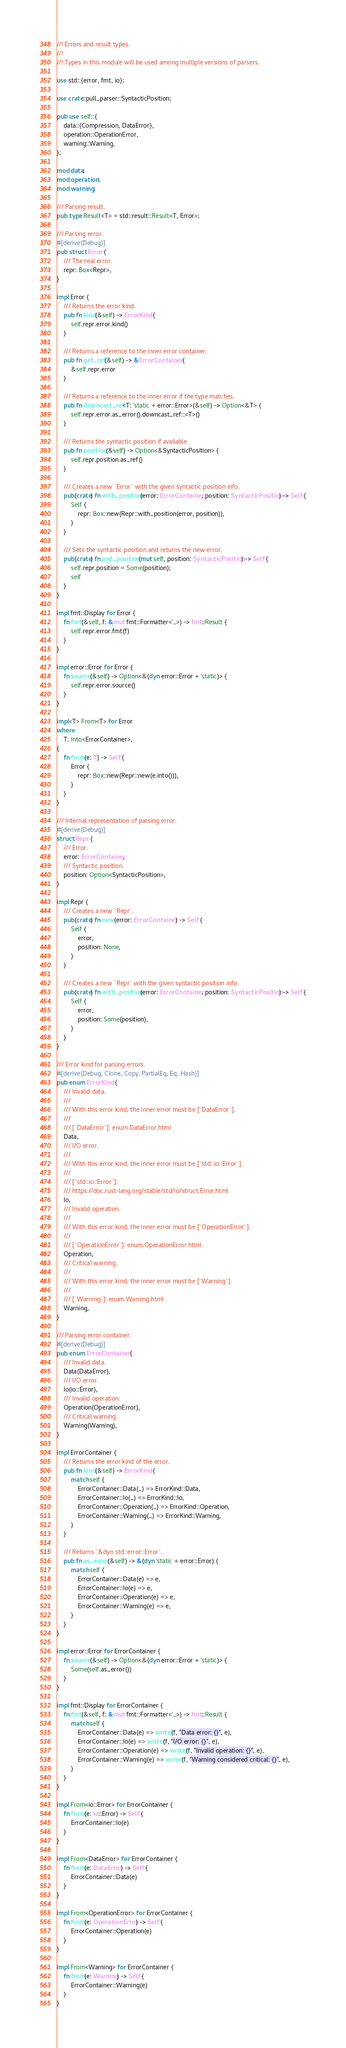Convert code to text. <code><loc_0><loc_0><loc_500><loc_500><_Rust_>//! Errors and result types.
//!
//! Types in this module will be used among multiple versions of parsers.

use std::{error, fmt, io};

use crate::pull_parser::SyntacticPosition;

pub use self::{
    data::{Compression, DataError},
    operation::OperationError,
    warning::Warning,
};

mod data;
mod operation;
mod warning;

/// Parsing result.
pub type Result<T> = std::result::Result<T, Error>;

/// Parsing error.
#[derive(Debug)]
pub struct Error {
    /// The real error.
    repr: Box<Repr>,
}

impl Error {
    /// Returns the error kind.
    pub fn kind(&self) -> ErrorKind {
        self.repr.error.kind()
    }

    /// Returns a reference to the inner error container.
    pub fn get_ref(&self) -> &ErrorContainer {
        &self.repr.error
    }

    /// Returns a reference to the inner error if the type matches.
    pub fn downcast_ref<T: 'static + error::Error>(&self) -> Option<&T> {
        self.repr.error.as_error().downcast_ref::<T>()
    }

    /// Returns the syntactic position if available.
    pub fn position(&self) -> Option<&SyntacticPosition> {
        self.repr.position.as_ref()
    }

    /// Creates a new `Error` with the given syntactic position info.
    pub(crate) fn with_position(error: ErrorContainer, position: SyntacticPosition) -> Self {
        Self {
            repr: Box::new(Repr::with_position(error, position)),
        }
    }

    /// Sets the syntactic position and returns the new error.
    pub(crate) fn and_position(mut self, position: SyntacticPosition) -> Self {
        self.repr.position = Some(position);
        self
    }
}

impl fmt::Display for Error {
    fn fmt(&self, f: &mut fmt::Formatter<'_>) -> fmt::Result {
        self.repr.error.fmt(f)
    }
}

impl error::Error for Error {
    fn source(&self) -> Option<&(dyn error::Error + 'static)> {
        self.repr.error.source()
    }
}

impl<T> From<T> for Error
where
    T: Into<ErrorContainer>,
{
    fn from(e: T) -> Self {
        Error {
            repr: Box::new(Repr::new(e.into())),
        }
    }
}

/// Internal representation of parsing error.
#[derive(Debug)]
struct Repr {
    /// Error.
    error: ErrorContainer,
    /// Syntactic position.
    position: Option<SyntacticPosition>,
}

impl Repr {
    /// Creates a new `Repr`.
    pub(crate) fn new(error: ErrorContainer) -> Self {
        Self {
            error,
            position: None,
        }
    }

    /// Creates a new `Repr` with the given syntactic position info.
    pub(crate) fn with_position(error: ErrorContainer, position: SyntacticPosition) -> Self {
        Self {
            error,
            position: Some(position),
        }
    }
}

/// Error kind for parsing errors.
#[derive(Debug, Clone, Copy, PartialEq, Eq, Hash)]
pub enum ErrorKind {
    /// Invalid data.
    ///
    /// With this error kind, the inner error must be [`DataError`].
    ///
    /// [`DataError`]: enum.DataError.html
    Data,
    /// I/O error.
    ///
    /// With this error kind, the inner error must be [`std::io::Error`].
    ///
    /// [`std::io::Error`]:
    /// https://doc.rust-lang.org/stable/std/io/struct.Error.html
    Io,
    /// Invalid operation.
    ///
    /// With this error kind, the inner error must be [`OperationError`].
    ///
    /// [`OperationError`]: enum.OperationError.html
    Operation,
    /// Critical warning.
    ///
    /// With this error kind, the inner error must be [`Warning`].
    ///
    /// [`Warning`]: enum.Warning.html
    Warning,
}

/// Parsing error container.
#[derive(Debug)]
pub enum ErrorContainer {
    /// Invalid data.
    Data(DataError),
    /// I/O error.
    Io(io::Error),
    /// Invalid operation.
    Operation(OperationError),
    /// Critical warning.
    Warning(Warning),
}

impl ErrorContainer {
    /// Returns the error kind of the error.
    pub fn kind(&self) -> ErrorKind {
        match self {
            ErrorContainer::Data(_) => ErrorKind::Data,
            ErrorContainer::Io(_) => ErrorKind::Io,
            ErrorContainer::Operation(_) => ErrorKind::Operation,
            ErrorContainer::Warning(_) => ErrorKind::Warning,
        }
    }

    /// Returns `&dyn std::error::Error`.
    pub fn as_error(&self) -> &(dyn 'static + error::Error) {
        match self {
            ErrorContainer::Data(e) => e,
            ErrorContainer::Io(e) => e,
            ErrorContainer::Operation(e) => e,
            ErrorContainer::Warning(e) => e,
        }
    }
}

impl error::Error for ErrorContainer {
    fn source(&self) -> Option<&(dyn error::Error + 'static)> {
        Some(self.as_error())
    }
}

impl fmt::Display for ErrorContainer {
    fn fmt(&self, f: &mut fmt::Formatter<'_>) -> fmt::Result {
        match self {
            ErrorContainer::Data(e) => write!(f, "Data error: {}", e),
            ErrorContainer::Io(e) => write!(f, "I/O error: {}", e),
            ErrorContainer::Operation(e) => write!(f, "Invalid operation: {}", e),
            ErrorContainer::Warning(e) => write!(f, "Warning considered critical: {}", e),
        }
    }
}

impl From<io::Error> for ErrorContainer {
    fn from(e: io::Error) -> Self {
        ErrorContainer::Io(e)
    }
}

impl From<DataError> for ErrorContainer {
    fn from(e: DataError) -> Self {
        ErrorContainer::Data(e)
    }
}

impl From<OperationError> for ErrorContainer {
    fn from(e: OperationError) -> Self {
        ErrorContainer::Operation(e)
    }
}

impl From<Warning> for ErrorContainer {
    fn from(e: Warning) -> Self {
        ErrorContainer::Warning(e)
    }
}
</code> 